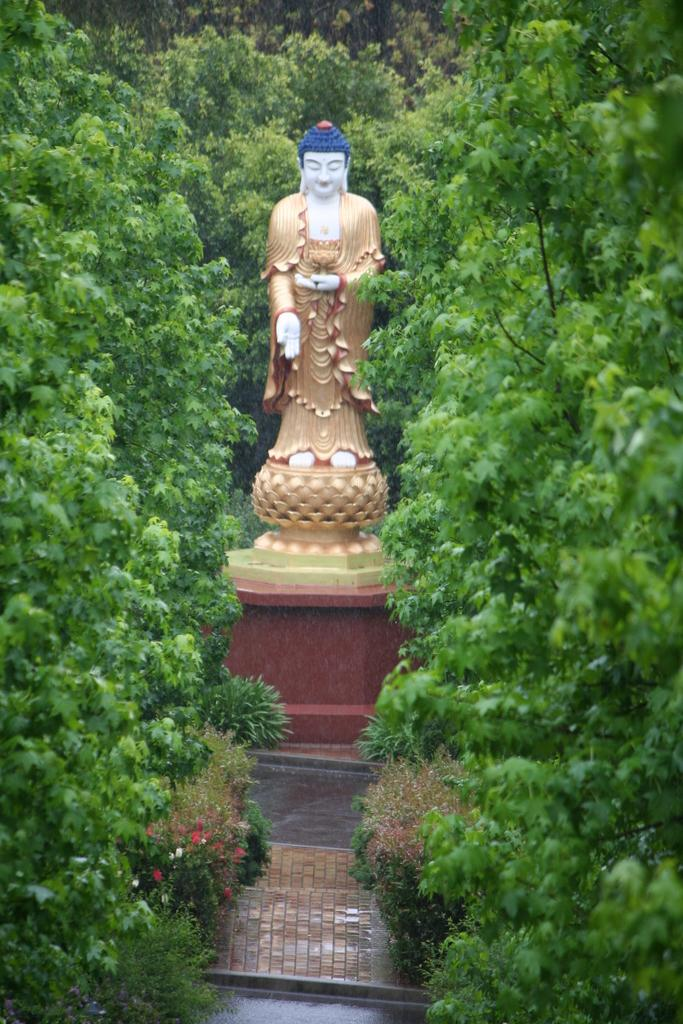What is the main subject in the image? There is a statue in the image. What can be seen in the background of the image? There are trees in the image. What is at the bottom of the image? There is a floor at the bottom of the image. What type of vegetation is present in the image? There are flowers on the plants in the image. What month is it in the image? The month cannot be determined from the image, as it does not contain any information about the time of year. 